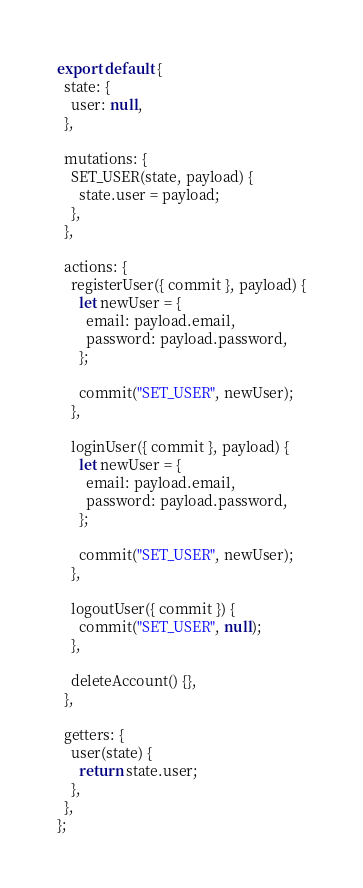<code> <loc_0><loc_0><loc_500><loc_500><_JavaScript_>export default {
  state: {
    user: null,
  },

  mutations: {
    SET_USER(state, payload) {
      state.user = payload;
    },
  },

  actions: {
    registerUser({ commit }, payload) {
      let newUser = {
        email: payload.email,
        password: payload.password,
      };

      commit("SET_USER", newUser);
    },

    loginUser({ commit }, payload) {
      let newUser = {
        email: payload.email,
        password: payload.password,
      };

      commit("SET_USER", newUser);
    },

    logoutUser({ commit }) {
      commit("SET_USER", null);
    },

    deleteAccount() {},
  },

  getters: {
    user(state) {
      return state.user;
    },
  },
};
</code> 